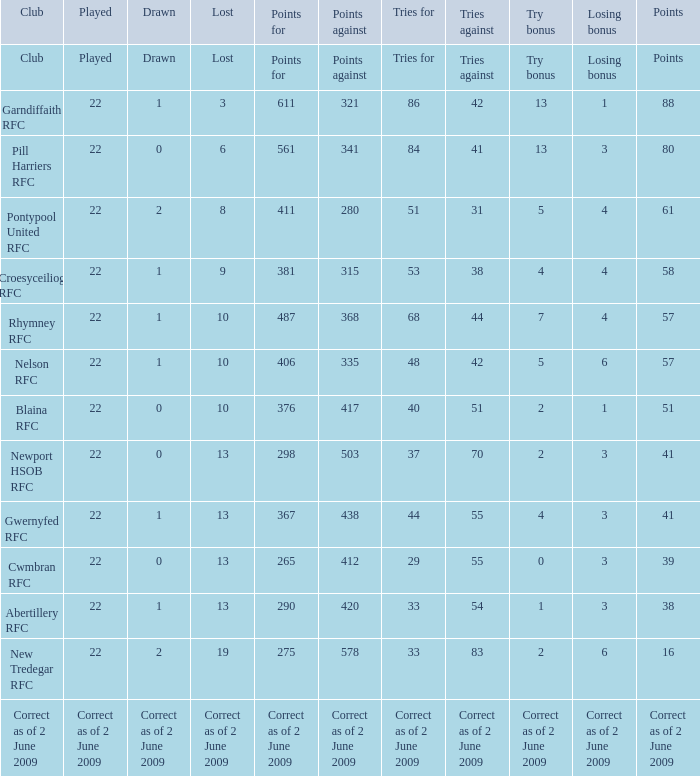With a losing bonus of 3 and 84 tries, how many points did the club concede? 341.0. 